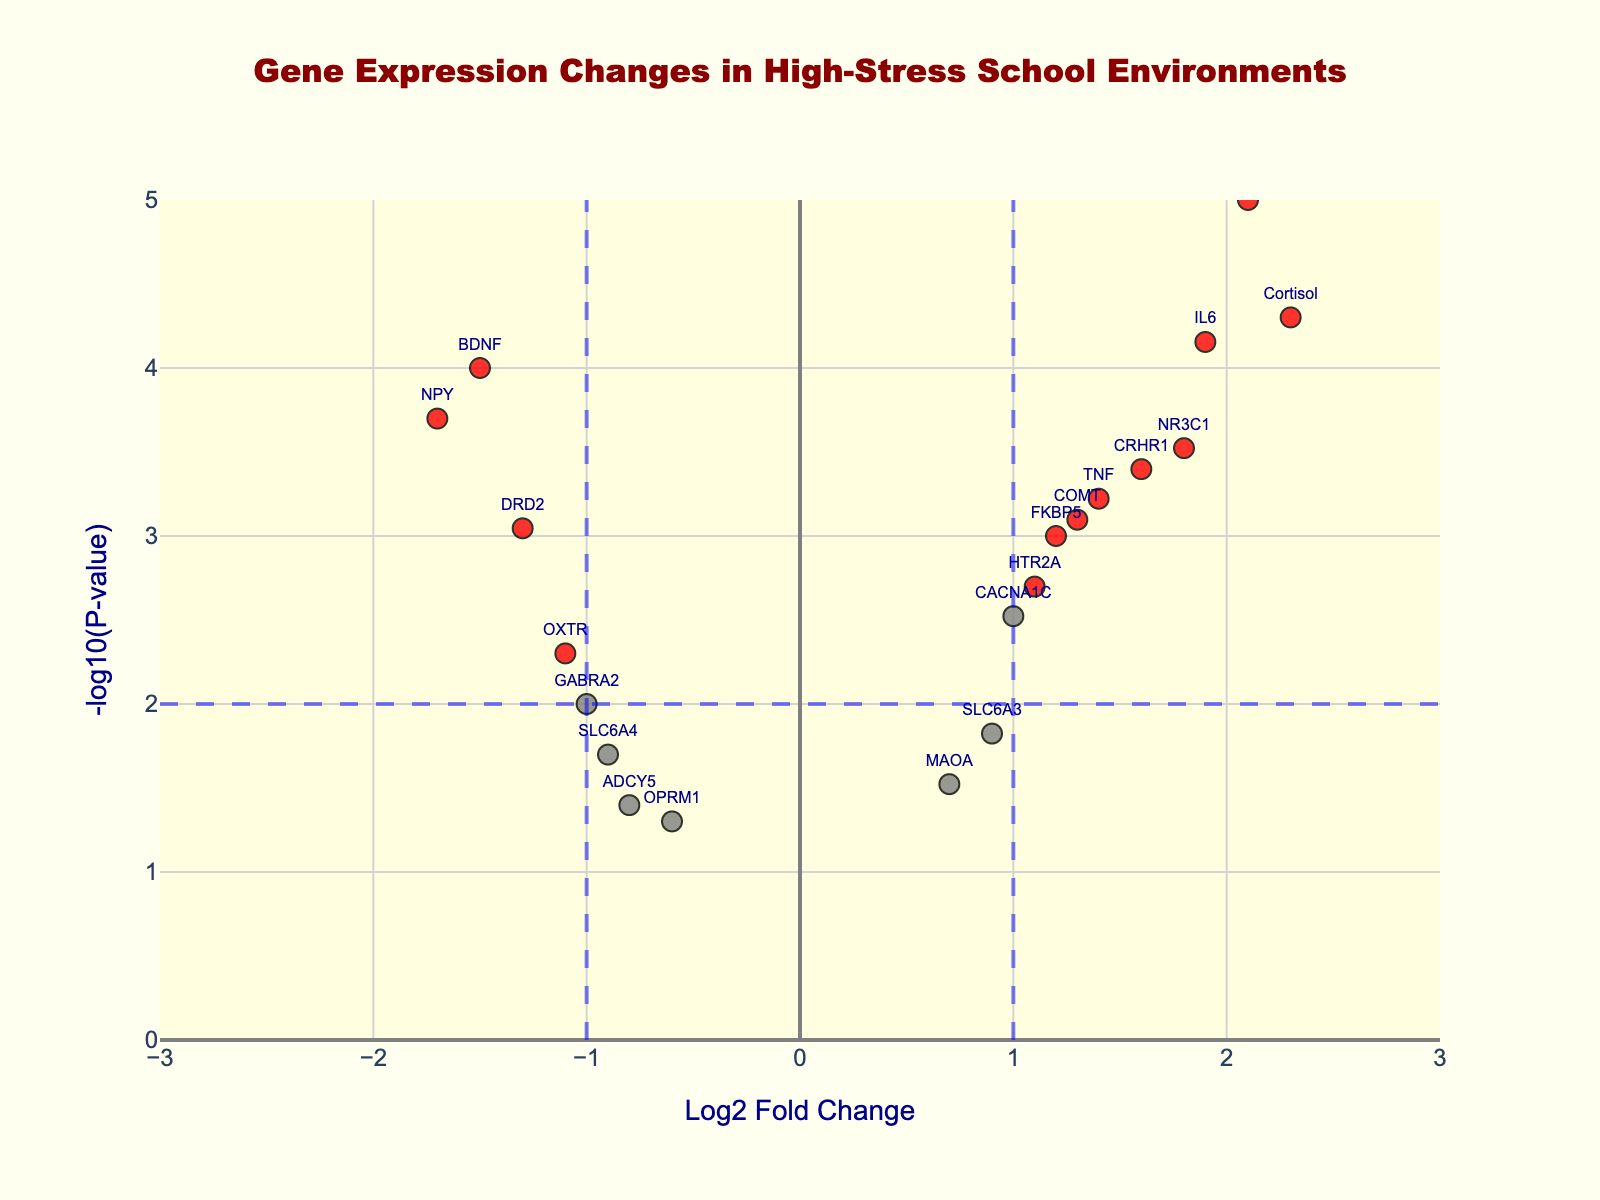What is the title of the plot? The title of the plot is located at the top center of the figure.
Answer: Gene Expression Changes in High-Stress School Environments How many genes have significant changes in both Log2 Fold Change greater than 1 and P-value less than 0.01? Significant changes can be identified by red-colored markers in the plot which indicates Log2 Fold Change greater than 1 and P-value less than 0.01.
Answer: 8 Which gene has the lowest -log10(P-value) among those with negative Log2 Fold Change? Check all the genes with negative Log2 Fold Change values and compare their corresponding -log10(P-value) values.
Answer: OPRM1 What are the coordinates (Log2 Fold Change, -log10(P-value)) of the gene IL6 in the plot? Find the label for IL6 on the plot and note the corresponding x and y values.
Answer: (1.9, 4.15) Which gene is more significantly down-regulated, NPY or BDNF? Compare the -log10(P-value) and Log2 Fold Change for both NPY and BDNF; the more down-regulated gene will have a lower Log2 Fold Change (more negative) and a higher -log10(P-value).
Answer: NPY Between the genes COMT and CRH, which has a more significant P-value? Compare the -log10(P-value) for COMT and CRH; the higher the -log10(P-value), the more significant the P-value is.
Answer: CRH Which is the closest gene to the intersection of the significance threshold lines (Log2 Fold Change = +/-1 and P-value = 0.01)? Identify the point of intersection at Log2 Fold Change = +/-1 and -log10(P-value) = 2, and find the nearest gene label.
Answer: DRD2 